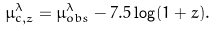<formula> <loc_0><loc_0><loc_500><loc_500>\mu ^ { \lambda } _ { c , z } = \mu ^ { \lambda } _ { o b s } - 7 . 5 \log ( 1 + z ) .</formula> 